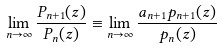<formula> <loc_0><loc_0><loc_500><loc_500>\lim _ { n \rightarrow \infty } \frac { P _ { n + 1 } ( z ) } { P _ { n } ( z ) } \equiv \lim _ { n \rightarrow \infty } \frac { a _ { n + 1 } p _ { n + 1 } ( z ) } { p _ { n } ( z ) }</formula> 